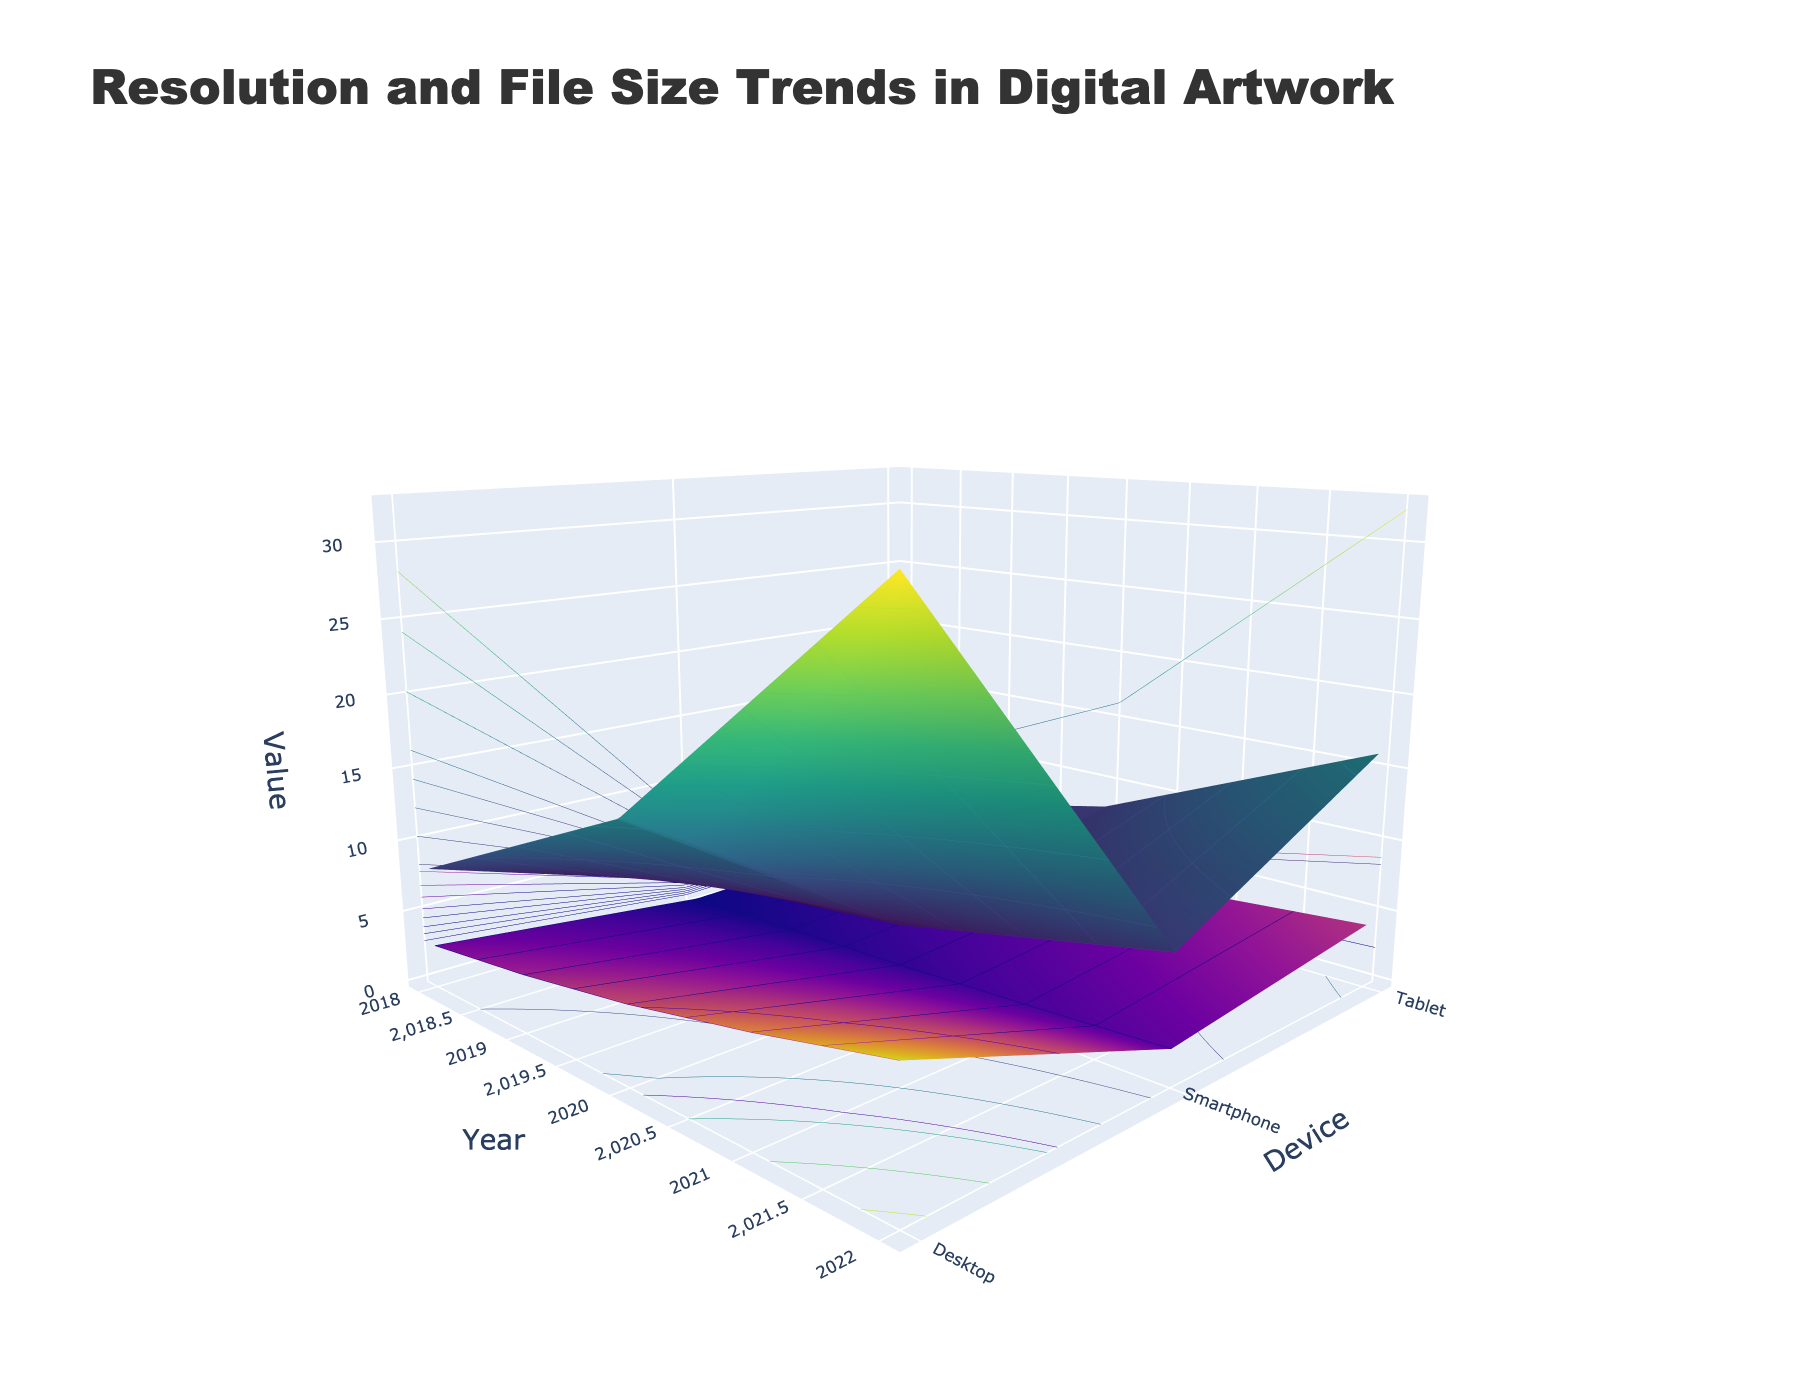What's the title of the plot? The title is located at the top of the plot and is set in a larger font size and bold text style.
Answer: Resolution and File Size Trends in Digital Artwork What are the axes titles? The axes titles are labeled along the axes in the chart. The x-axis is labeled 'Year', the y-axis is labeled 'Device', and the z-axis is labeled 'Value'.
Answer: Year, Device, Value Which year had the highest resolution for desktops? Look at the surface plot for Resolution (MP) specifically for the 'Desktop' device type. The highest point on this surface corresponds to the highest resolution. Trace down the x-axis to find the year.
Answer: 2022 How did the file size trend for smartphones change from 2018 to 2022? Examine the surface plot that represents File Size (MB) for the 'Smartphone' device type. Observe the values and how they change as you move along the x-axis from 2018 to 2022.
Answer: It increased Which device type had the highest file size increase from 2018 to 2022? Compare the increase in file size values from 2018 to 2022 across the different devices (Smartphone, Tablet, Desktop) on the File Size (MB) surface. Identify the device with the largest change.
Answer: Desktop Did any device have a higher resolution than 32 MP at any year? Examine the Resolution (MP) surface plot across all device types and years to determine if any points exceed the value of 32 MP.
Answer: No Compare the file sizes for tablets and desktops in 2019. Which one is larger? Look at the File Size (MB) values for the year 2019 specifically for 'Tablet' and 'Desktop' devices. Compare these two values directly.
Answer: Desktop What trend can be seen in the resolution for smartphones over the years? Examine the Resolution (MP) values on the surface plot for the 'Smartphone' device type from 2018 to 2022. Observe whether the values are increasing, decreasing, or constant.
Answer: Increasing Which device had a higher resolution in 2018, smartphones or tablets? Compare the Resolution (MP) values for the year 2018 specifically for 'Smartphone' and 'Tablet' devices on the surface plot.
Answer: Tablets 